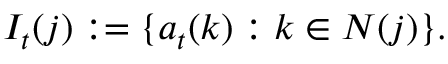Convert formula to latex. <formula><loc_0><loc_0><loc_500><loc_500>I _ { t } ( j ) \colon = \{ a _ { t } ( k ) \colon k \in N ( j ) \} .</formula> 